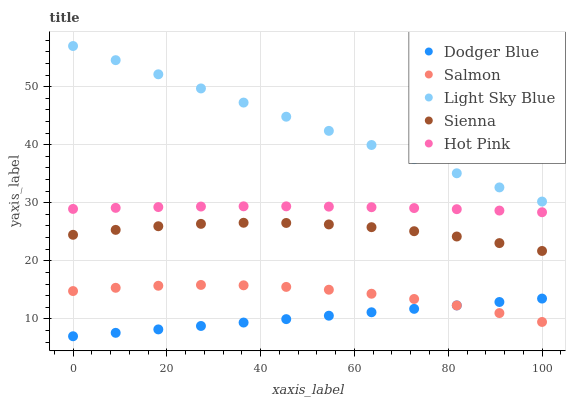Does Dodger Blue have the minimum area under the curve?
Answer yes or no. Yes. Does Light Sky Blue have the maximum area under the curve?
Answer yes or no. Yes. Does Salmon have the minimum area under the curve?
Answer yes or no. No. Does Salmon have the maximum area under the curve?
Answer yes or no. No. Is Dodger Blue the smoothest?
Answer yes or no. Yes. Is Sienna the roughest?
Answer yes or no. Yes. Is Salmon the smoothest?
Answer yes or no. No. Is Salmon the roughest?
Answer yes or no. No. Does Dodger Blue have the lowest value?
Answer yes or no. Yes. Does Salmon have the lowest value?
Answer yes or no. No. Does Light Sky Blue have the highest value?
Answer yes or no. Yes. Does Salmon have the highest value?
Answer yes or no. No. Is Salmon less than Sienna?
Answer yes or no. Yes. Is Sienna greater than Dodger Blue?
Answer yes or no. Yes. Does Dodger Blue intersect Salmon?
Answer yes or no. Yes. Is Dodger Blue less than Salmon?
Answer yes or no. No. Is Dodger Blue greater than Salmon?
Answer yes or no. No. Does Salmon intersect Sienna?
Answer yes or no. No. 